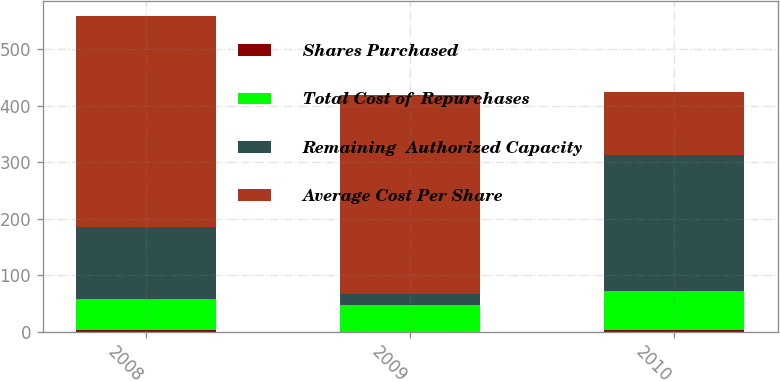<chart> <loc_0><loc_0><loc_500><loc_500><stacked_bar_chart><ecel><fcel>2008<fcel>2009<fcel>2010<nl><fcel>Shares Purchased<fcel>2.3<fcel>0.4<fcel>3.5<nl><fcel>Total Cost of  Repurchases<fcel>55.49<fcel>46.52<fcel>68.57<nl><fcel>Remaining  Authorized Capacity<fcel>128<fcel>20<fcel>241<nl><fcel>Average Cost Per Share<fcel>372<fcel>352<fcel>111<nl></chart> 